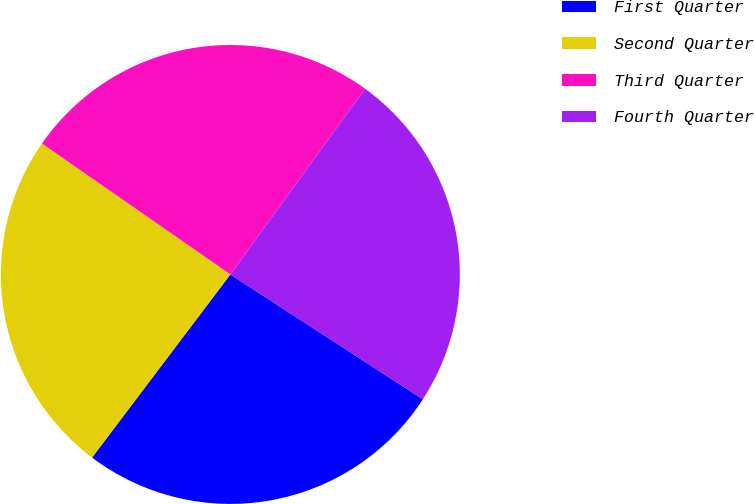Convert chart to OTSL. <chart><loc_0><loc_0><loc_500><loc_500><pie_chart><fcel>First Quarter<fcel>Second Quarter<fcel>Third Quarter<fcel>Fourth Quarter<nl><fcel>26.14%<fcel>24.37%<fcel>25.33%<fcel>24.17%<nl></chart> 